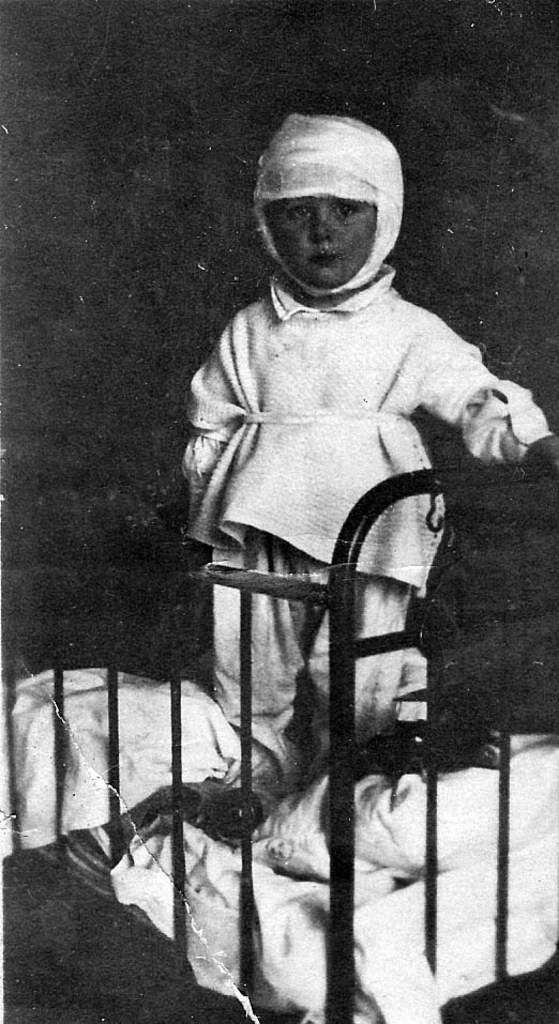What is the kid doing in the image? The kid is standing on the bed. Can you describe the background of the image? The background of the image is dark. What type of waves can be seen in the image? There are no waves present in the image; it features a kid standing on a bed with a dark background. 